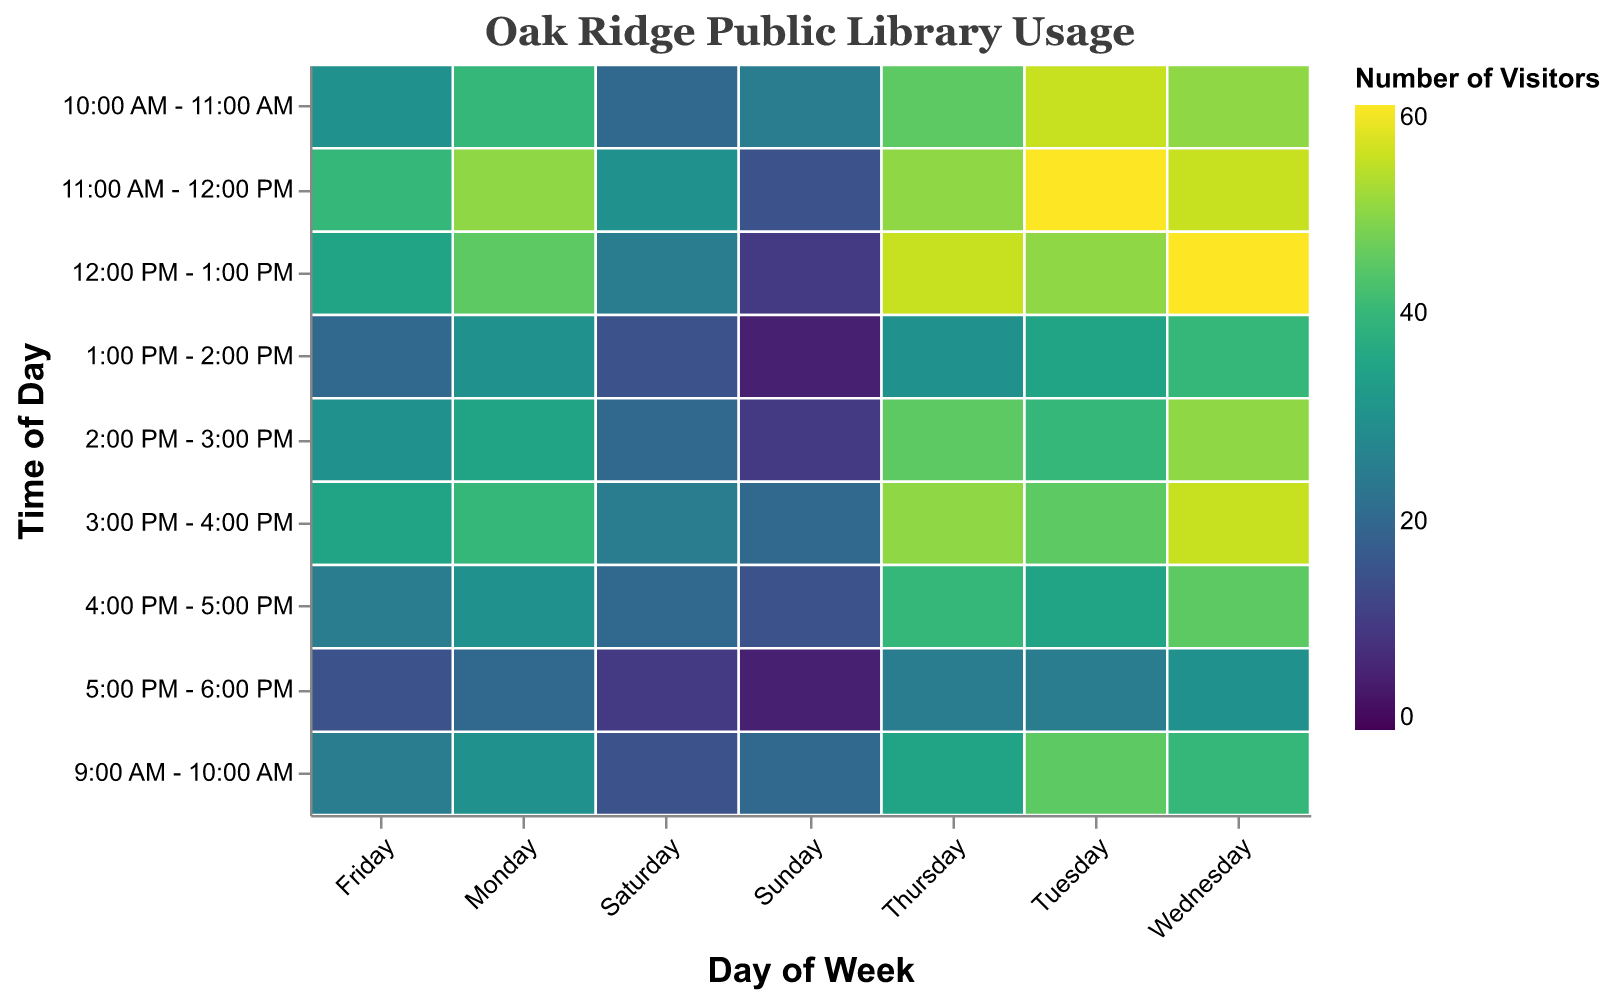What is the title of the heatmap? The title is displayed at the top of the heatmap, reading "Oak Ridge Public Library Usage".
Answer: Oak Ridge Public Library Usage Which day of the week shows the highest usage at 11:00 AM - 12:00 PM? By looking at the heatmap for the 11:00 AM - 12:00 PM row, you can see the highest value is on Tuesday, which is 60.
Answer: Tuesday During what time period on Wednesday is the library least used? Check the values under the Wednesday column; the time slot 5:00 PM - 6:00 PM has the lowest value of 30 visitors.
Answer: 5:00 PM - 6:00 PM What is the overall busiest time of day during the week? Observing all times of the day across all days, the time slot 11:00 AM - 12:00 PM has the highest values, with Tuesday at 60 being the maximum.
Answer: 11:00 AM - 12:00 PM How does the usage pattern change from 2:00 PM to 3:00 PM on Friday? On Friday, from 2:00 PM to 3:00 PM, the visitors increase from 30 to 35.
Answer: Increase What is the average number of visitors on Thursday from 10:00 AM to 2:00 PM? Sum the values for Thursday from 10:00 AM to 2:00 PM (45, 50, 55, 30) which equals 180, then divide by the number of time slots (4), resulting in an average of 45.
Answer: 45 Which day has the lowest overall usage throughout the day? Summing up all the values for each day, Sunday has the lowest overall usage with values (20, 25, 15, 10, 5, 10, 20, 15, 5) adding up to 125.
Answer: Sunday Compare the usage patterns of Monday and Saturday. Which day generally has a higher number of visitors? Comparing the values of Monday and Saturday across all times, Monday consistently has higher values.
Answer: Monday What is the range of the number of visitors on Friday from 9:00 AM to 5:00 PM? The range is calculated by subtracting the minimum (15) from the maximum (40) values for Friday within this timeframe, yielding a range of 25.
Answer: 25 Which two consecutive hours have the biggest increase in visitors on Wednesday? On Wednesday, the biggest increase between consecutive hours is from 12:00 PM - 1:00 PM (60) to 1:00 PM - 2:00 PM (40), showing an increase of 20.
Answer: 12:00 PM - 1:00 PM to 1:00 PM - 2:00 PM 